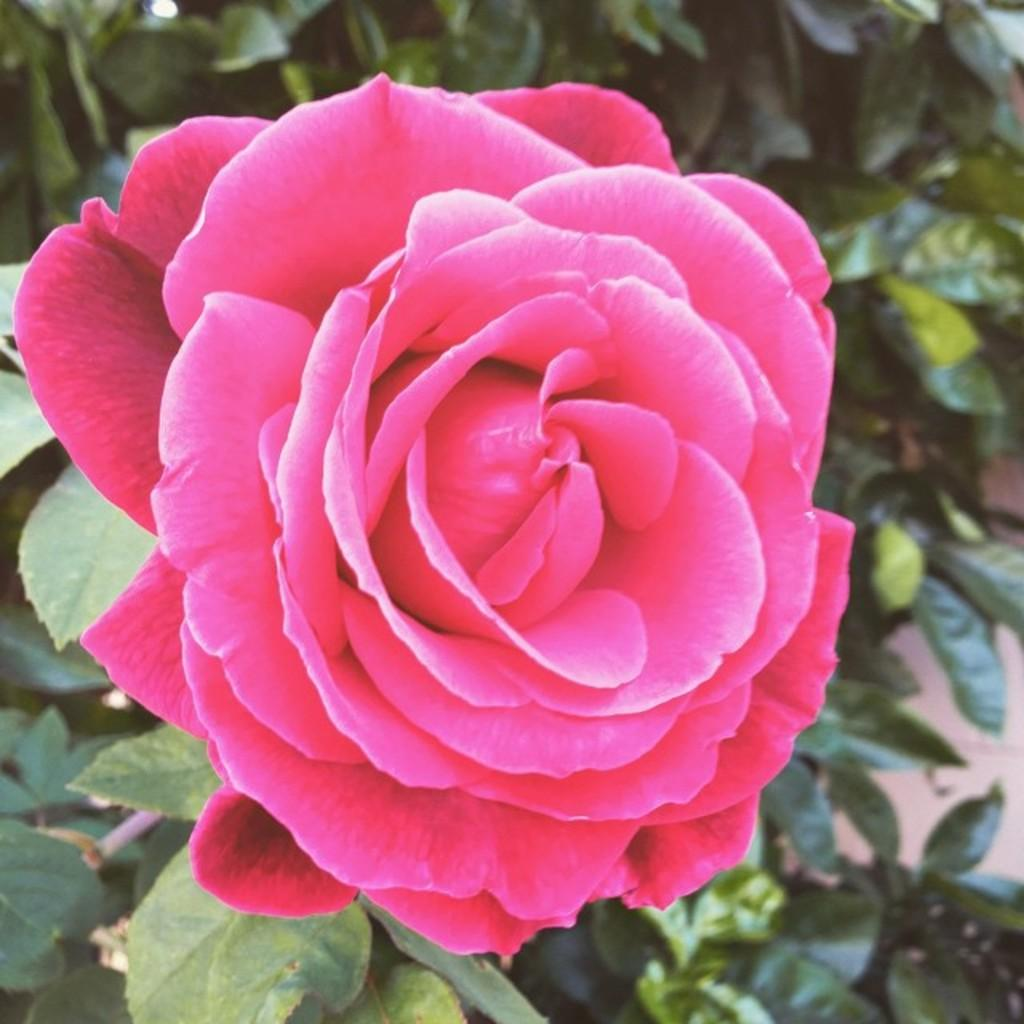What type of flower is in the image? There is a rose flower in the image. What color is the rose flower? The rose flower is pink in color. What can be seen in the background of the image? There are plants or trees in the background of the image. How many guitars are placed on the beds in the image? There are no guitars or beds present in the image; it features a pink rose flower and plants or trees in the background. 